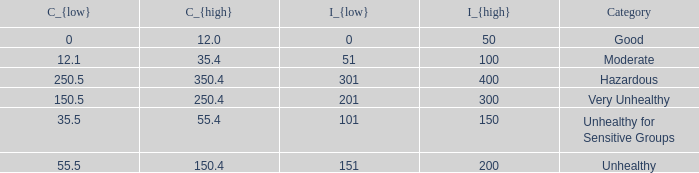What's the C_{low} value when C_{high} is 12.0? 0.0. 